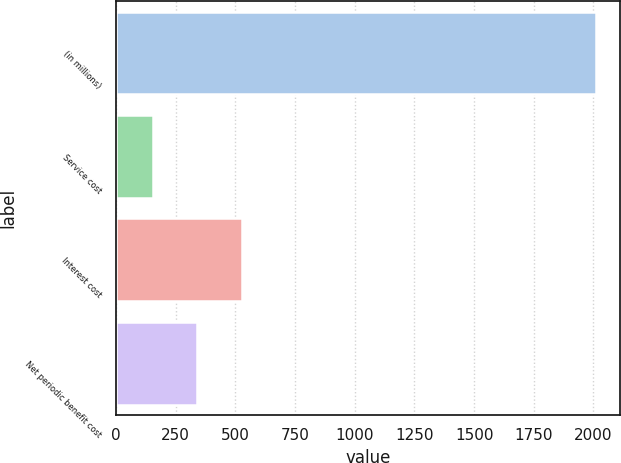Convert chart. <chart><loc_0><loc_0><loc_500><loc_500><bar_chart><fcel>(in millions)<fcel>Service cost<fcel>Interest cost<fcel>Net periodic benefit cost<nl><fcel>2012<fcel>154<fcel>525.6<fcel>339.8<nl></chart> 